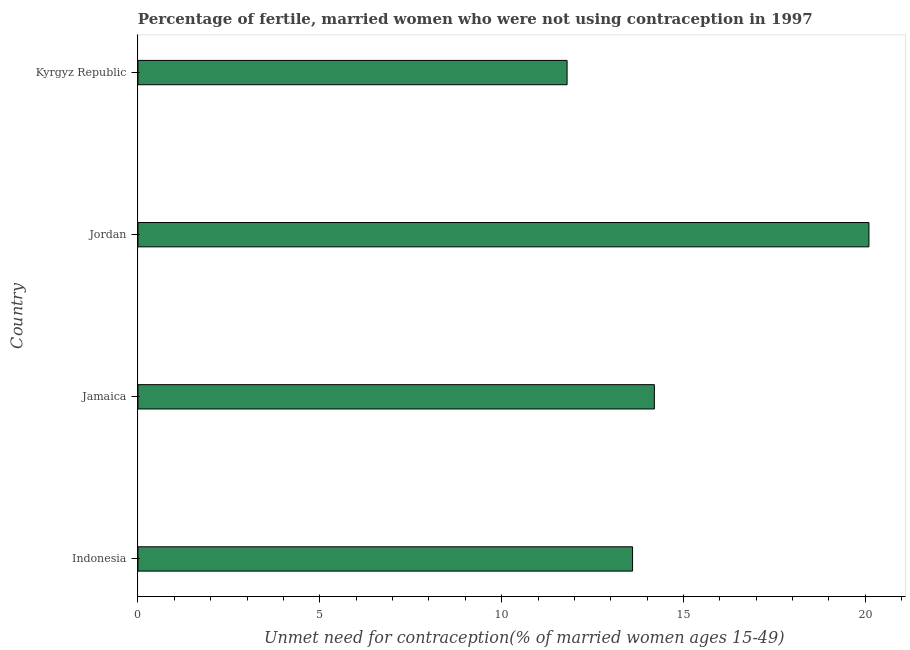What is the title of the graph?
Offer a very short reply. Percentage of fertile, married women who were not using contraception in 1997. What is the label or title of the X-axis?
Your response must be concise.  Unmet need for contraception(% of married women ages 15-49). What is the number of married women who are not using contraception in Kyrgyz Republic?
Your answer should be very brief. 11.8. Across all countries, what is the maximum number of married women who are not using contraception?
Your response must be concise. 20.1. Across all countries, what is the minimum number of married women who are not using contraception?
Offer a very short reply. 11.8. In which country was the number of married women who are not using contraception maximum?
Keep it short and to the point. Jordan. In which country was the number of married women who are not using contraception minimum?
Ensure brevity in your answer.  Kyrgyz Republic. What is the sum of the number of married women who are not using contraception?
Offer a terse response. 59.7. What is the average number of married women who are not using contraception per country?
Keep it short and to the point. 14.93. What is the median number of married women who are not using contraception?
Make the answer very short. 13.9. In how many countries, is the number of married women who are not using contraception greater than 4 %?
Your answer should be compact. 4. What is the ratio of the number of married women who are not using contraception in Indonesia to that in Kyrgyz Republic?
Provide a succinct answer. 1.15. What is the difference between the highest and the lowest number of married women who are not using contraception?
Provide a succinct answer. 8.3. How many bars are there?
Offer a very short reply. 4. How many countries are there in the graph?
Give a very brief answer. 4. What is the difference between two consecutive major ticks on the X-axis?
Make the answer very short. 5. Are the values on the major ticks of X-axis written in scientific E-notation?
Provide a succinct answer. No. What is the  Unmet need for contraception(% of married women ages 15-49) of Indonesia?
Your answer should be very brief. 13.6. What is the  Unmet need for contraception(% of married women ages 15-49) in Jamaica?
Give a very brief answer. 14.2. What is the  Unmet need for contraception(% of married women ages 15-49) of Jordan?
Keep it short and to the point. 20.1. What is the ratio of the  Unmet need for contraception(% of married women ages 15-49) in Indonesia to that in Jamaica?
Offer a terse response. 0.96. What is the ratio of the  Unmet need for contraception(% of married women ages 15-49) in Indonesia to that in Jordan?
Ensure brevity in your answer.  0.68. What is the ratio of the  Unmet need for contraception(% of married women ages 15-49) in Indonesia to that in Kyrgyz Republic?
Keep it short and to the point. 1.15. What is the ratio of the  Unmet need for contraception(% of married women ages 15-49) in Jamaica to that in Jordan?
Keep it short and to the point. 0.71. What is the ratio of the  Unmet need for contraception(% of married women ages 15-49) in Jamaica to that in Kyrgyz Republic?
Keep it short and to the point. 1.2. What is the ratio of the  Unmet need for contraception(% of married women ages 15-49) in Jordan to that in Kyrgyz Republic?
Ensure brevity in your answer.  1.7. 